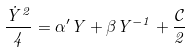Convert formula to latex. <formula><loc_0><loc_0><loc_500><loc_500>\frac { \dot { Y } ^ { 2 } } { 4 } = \alpha ^ { \prime } Y + \beta Y ^ { - 1 } + \frac { \mathcal { C } } { 2 }</formula> 